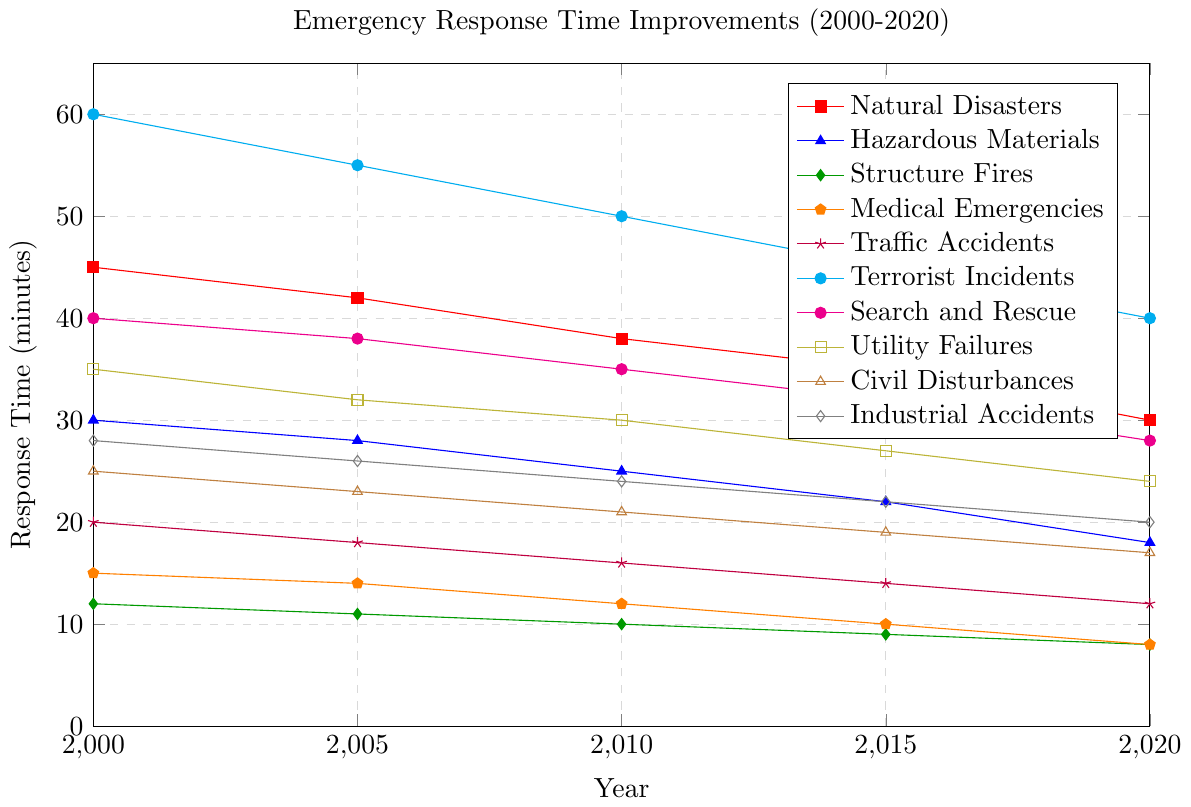What's the overall trend for the response times of Medical Emergencies from 2000 to 2020? The response times for Medical Emergencies show a decreasing trend from 15 minutes in 2000 to 8 minutes in 2020.
Answer: Decreasing Which incident type had the largest improvement in response time from 2000 to 2020? The largest improvement can be found by calculating the difference in response time between 2000 and 2020 for each incident type. The largest decrease is for Terrorist Incidents, from 60 minutes to 40 minutes, a decrease of 20 minutes.
Answer: Terrorist Incidents In 2020, which incident type had the shortest response time? By comparing the response times for all incident types in 2020, Structure Fires and Medical Emergencies both have the shortest response time of 8 minutes.
Answer: Structure Fires and Medical Emergencies How much did the response time for Traffic Accidents improve from 2000 to 2020? The response time for Traffic Accidents in 2000 was 20 minutes, and in 2020 it was 12 minutes. The improvement is 20 - 12 = 8 minutes.
Answer: 8 minutes Which incident type had the least improvement in response time from 2000 to 2020? The least improvement can be found by calculating the difference between 2000 and 2020 for each incident type. Structure Fires improved from 12 minutes to 8 minutes, only a 4-minute improvement, which is the smallest among all types.
Answer: Structure Fires What was the average response time for Natural Disasters over the 5 time points? Adding the response times for Natural Disasters (45 + 42 + 38 + 35 + 30) gives 190 minutes. Dividing by 5, the average response time is 190/5 = 38 minutes.
Answer: 38 minutes In which year did the response time for Hazardous Materials first drop below 20 minutes? Checking the response times for Hazardous Materials, it first drops below 20 minutes in 2020, with a time of 18 minutes.
Answer: 2020 How much faster was the response to Utility Failures in 2015 compared to Civil Disturbances in the same year? In 2015, Utility Failures had a response time of 27 minutes, and Civil Disturbances had a response time of 19 minutes. The difference is 27 - 19 = 8 minutes.
Answer: 8 minutes Between 2005 and 2010, which incident type saw the greatest improvement in response time? By calculating the difference between 2005 and 2010 for each incident type, Traffic Accidents saw the greatest improvement, from 18 minutes to 16 minutes, a decrease of 2 minutes.
Answer: Traffic Accidents How did the response time for Search and Rescue incidents change from 2000 to 2020? In 2000, the response time for Search and Rescue was 40 minutes. By 2020, it decreased to 28 minutes. So, there was an overall decrease of 40 - 28 = 12 minutes.
Answer: Decreased by 12 minutes 